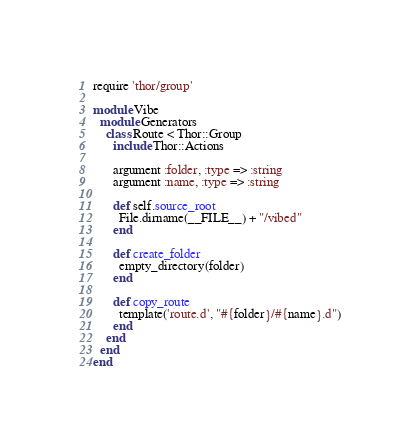<code> <loc_0><loc_0><loc_500><loc_500><_Ruby_>require 'thor/group'

module Vibe
  module Generators
    class Route < Thor::Group
      include Thor::Actions

      argument :folder, :type => :string
      argument :name, :type => :string

      def self.source_root
        File.dirname(__FILE__) + "/vibed"
      end

      def create_folder
        empty_directory(folder)
      end

      def copy_route
        template('route.d', "#{folder}/#{name}.d")
      end
    end
  end
end</code> 